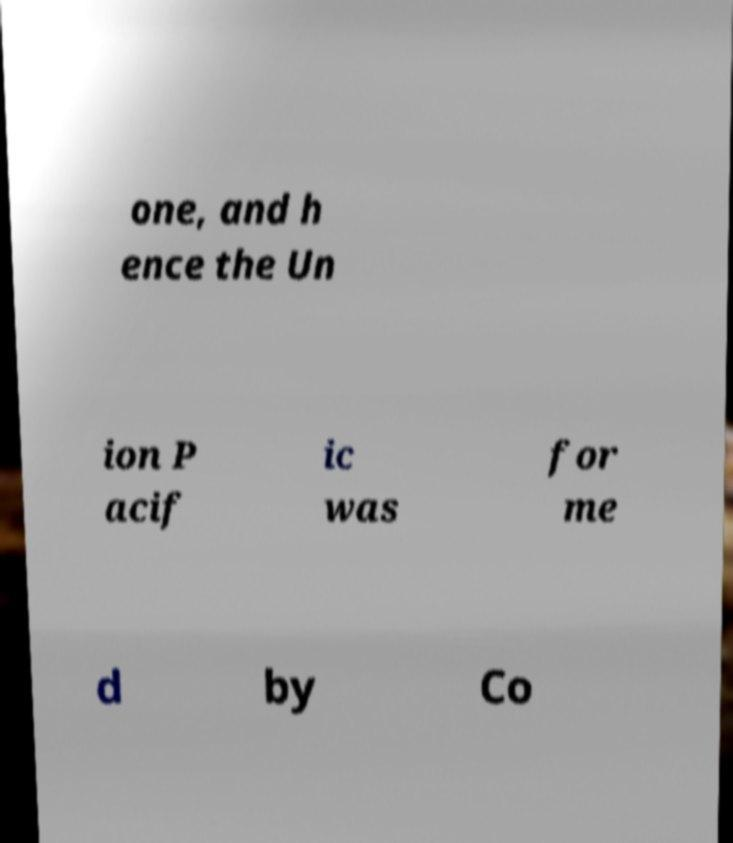Please read and relay the text visible in this image. What does it say? one, and h ence the Un ion P acif ic was for me d by Co 